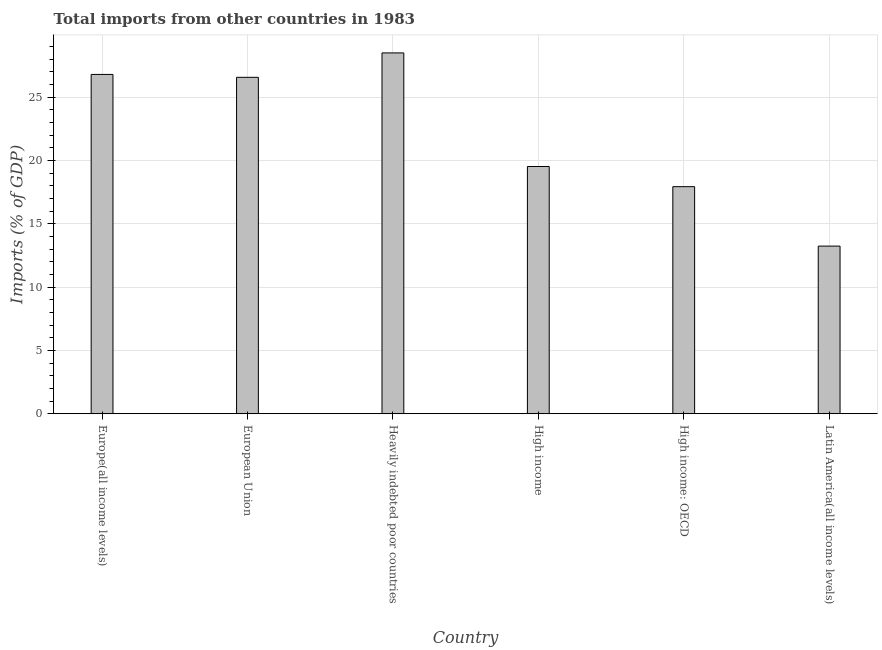Does the graph contain any zero values?
Provide a succinct answer. No. Does the graph contain grids?
Provide a short and direct response. Yes. What is the title of the graph?
Keep it short and to the point. Total imports from other countries in 1983. What is the label or title of the Y-axis?
Make the answer very short. Imports (% of GDP). What is the total imports in Heavily indebted poor countries?
Ensure brevity in your answer.  28.51. Across all countries, what is the maximum total imports?
Provide a succinct answer. 28.51. Across all countries, what is the minimum total imports?
Your answer should be compact. 13.24. In which country was the total imports maximum?
Make the answer very short. Heavily indebted poor countries. In which country was the total imports minimum?
Your answer should be very brief. Latin America(all income levels). What is the sum of the total imports?
Your response must be concise. 132.61. What is the difference between the total imports in Europe(all income levels) and Latin America(all income levels)?
Keep it short and to the point. 13.56. What is the average total imports per country?
Make the answer very short. 22.1. What is the median total imports?
Keep it short and to the point. 23.06. What is the ratio of the total imports in European Union to that in High income?
Give a very brief answer. 1.36. What is the difference between the highest and the second highest total imports?
Your answer should be compact. 1.7. What is the difference between the highest and the lowest total imports?
Provide a succinct answer. 15.26. In how many countries, is the total imports greater than the average total imports taken over all countries?
Your answer should be compact. 3. How many bars are there?
Your answer should be compact. 6. Are all the bars in the graph horizontal?
Keep it short and to the point. No. How many countries are there in the graph?
Your answer should be compact. 6. What is the Imports (% of GDP) of Europe(all income levels)?
Offer a terse response. 26.81. What is the Imports (% of GDP) in European Union?
Offer a very short reply. 26.58. What is the Imports (% of GDP) in Heavily indebted poor countries?
Offer a terse response. 28.51. What is the Imports (% of GDP) of High income?
Your response must be concise. 19.53. What is the Imports (% of GDP) in High income: OECD?
Offer a very short reply. 17.94. What is the Imports (% of GDP) in Latin America(all income levels)?
Ensure brevity in your answer.  13.24. What is the difference between the Imports (% of GDP) in Europe(all income levels) and European Union?
Offer a terse response. 0.23. What is the difference between the Imports (% of GDP) in Europe(all income levels) and Heavily indebted poor countries?
Give a very brief answer. -1.7. What is the difference between the Imports (% of GDP) in Europe(all income levels) and High income?
Ensure brevity in your answer.  7.27. What is the difference between the Imports (% of GDP) in Europe(all income levels) and High income: OECD?
Your answer should be very brief. 8.87. What is the difference between the Imports (% of GDP) in Europe(all income levels) and Latin America(all income levels)?
Provide a short and direct response. 13.56. What is the difference between the Imports (% of GDP) in European Union and Heavily indebted poor countries?
Provide a succinct answer. -1.93. What is the difference between the Imports (% of GDP) in European Union and High income?
Provide a succinct answer. 7.05. What is the difference between the Imports (% of GDP) in European Union and High income: OECD?
Offer a very short reply. 8.64. What is the difference between the Imports (% of GDP) in European Union and Latin America(all income levels)?
Make the answer very short. 13.34. What is the difference between the Imports (% of GDP) in Heavily indebted poor countries and High income?
Offer a very short reply. 8.97. What is the difference between the Imports (% of GDP) in Heavily indebted poor countries and High income: OECD?
Provide a short and direct response. 10.57. What is the difference between the Imports (% of GDP) in Heavily indebted poor countries and Latin America(all income levels)?
Make the answer very short. 15.26. What is the difference between the Imports (% of GDP) in High income and High income: OECD?
Ensure brevity in your answer.  1.59. What is the difference between the Imports (% of GDP) in High income and Latin America(all income levels)?
Offer a very short reply. 6.29. What is the difference between the Imports (% of GDP) in High income: OECD and Latin America(all income levels)?
Your answer should be compact. 4.7. What is the ratio of the Imports (% of GDP) in Europe(all income levels) to that in European Union?
Your answer should be compact. 1.01. What is the ratio of the Imports (% of GDP) in Europe(all income levels) to that in High income?
Offer a very short reply. 1.37. What is the ratio of the Imports (% of GDP) in Europe(all income levels) to that in High income: OECD?
Your answer should be very brief. 1.49. What is the ratio of the Imports (% of GDP) in Europe(all income levels) to that in Latin America(all income levels)?
Offer a very short reply. 2.02. What is the ratio of the Imports (% of GDP) in European Union to that in Heavily indebted poor countries?
Give a very brief answer. 0.93. What is the ratio of the Imports (% of GDP) in European Union to that in High income?
Make the answer very short. 1.36. What is the ratio of the Imports (% of GDP) in European Union to that in High income: OECD?
Offer a terse response. 1.48. What is the ratio of the Imports (% of GDP) in European Union to that in Latin America(all income levels)?
Keep it short and to the point. 2.01. What is the ratio of the Imports (% of GDP) in Heavily indebted poor countries to that in High income?
Your answer should be compact. 1.46. What is the ratio of the Imports (% of GDP) in Heavily indebted poor countries to that in High income: OECD?
Give a very brief answer. 1.59. What is the ratio of the Imports (% of GDP) in Heavily indebted poor countries to that in Latin America(all income levels)?
Provide a succinct answer. 2.15. What is the ratio of the Imports (% of GDP) in High income to that in High income: OECD?
Make the answer very short. 1.09. What is the ratio of the Imports (% of GDP) in High income to that in Latin America(all income levels)?
Ensure brevity in your answer.  1.48. What is the ratio of the Imports (% of GDP) in High income: OECD to that in Latin America(all income levels)?
Provide a short and direct response. 1.35. 